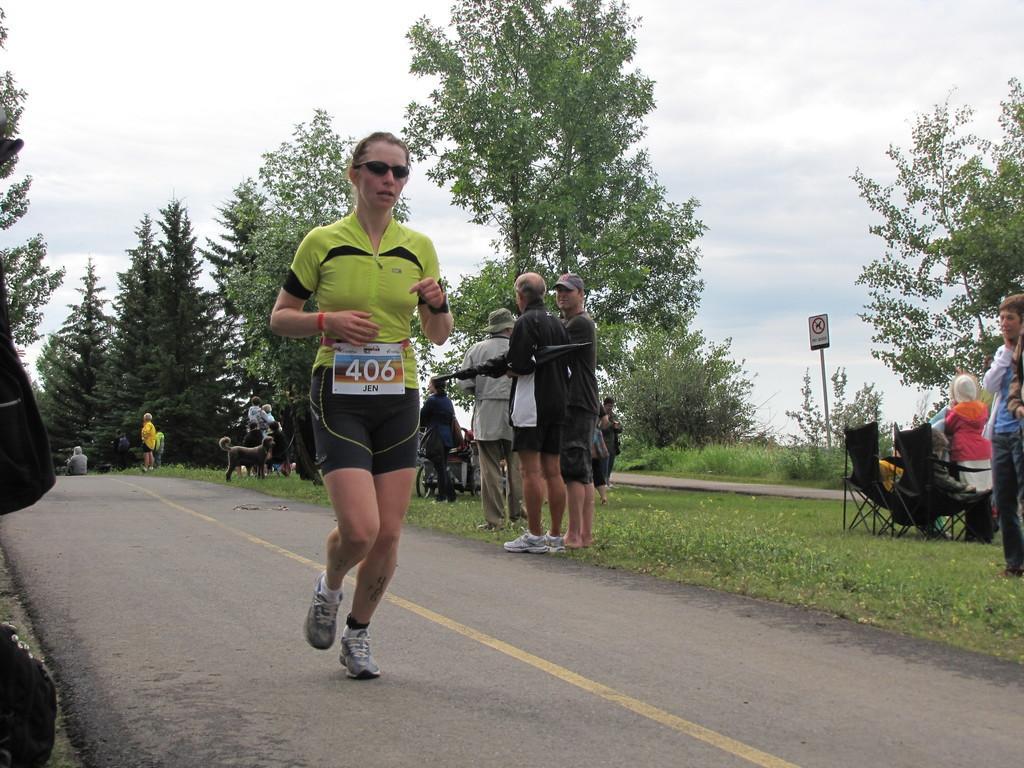Describe this image in one or two sentences. In the center of the image, we can see a person wearing a board, glasses and running on the road and in the background, we can see some other people and one of them is holding an umbrella and some are wearing caps and we can see chairs, trees, a board and we can see an animal and bicycles. At the top, there is sky. 